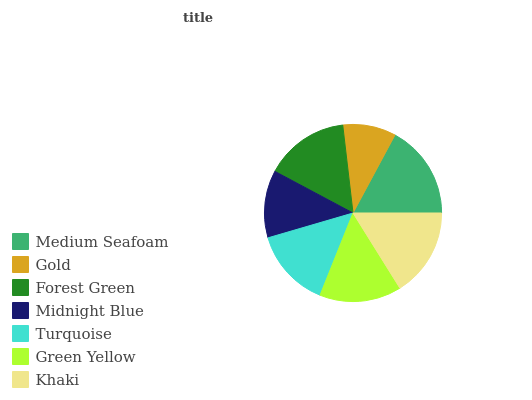Is Gold the minimum?
Answer yes or no. Yes. Is Medium Seafoam the maximum?
Answer yes or no. Yes. Is Forest Green the minimum?
Answer yes or no. No. Is Forest Green the maximum?
Answer yes or no. No. Is Forest Green greater than Gold?
Answer yes or no. Yes. Is Gold less than Forest Green?
Answer yes or no. Yes. Is Gold greater than Forest Green?
Answer yes or no. No. Is Forest Green less than Gold?
Answer yes or no. No. Is Green Yellow the high median?
Answer yes or no. Yes. Is Green Yellow the low median?
Answer yes or no. Yes. Is Khaki the high median?
Answer yes or no. No. Is Gold the low median?
Answer yes or no. No. 